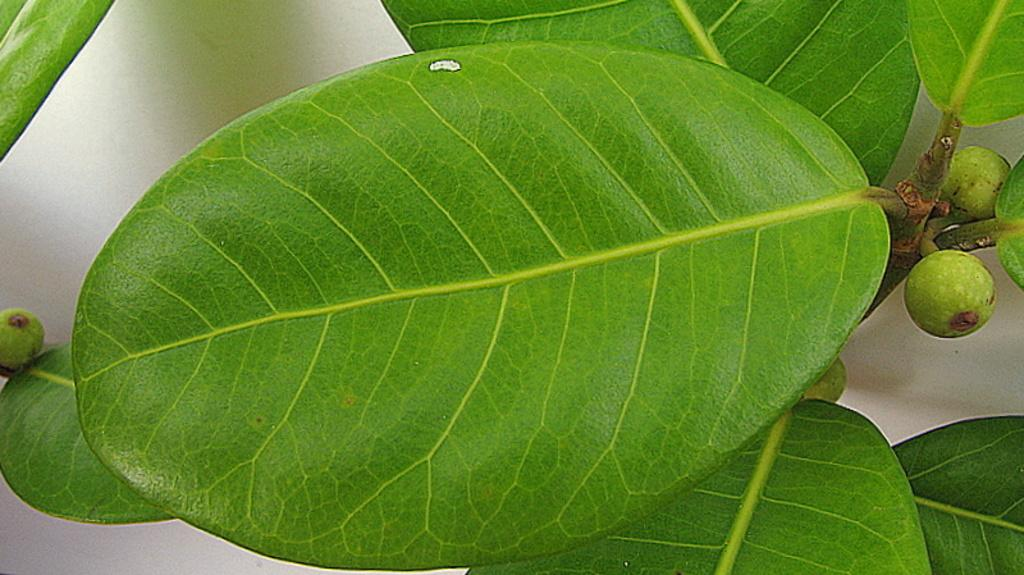What type of vegetation can be seen in the image? There are leaves in the image. What is the color of the leaves? The leaves are green in color. What else is present in the image besides leaves? There are fruits in the image. What is the color of the fruits? The fruits are green in color. How does the desire for a knot affect the range of the fruits in the image? There is no mention of desire or knots in the image, and the range of the fruits is not affected by any such factors. 